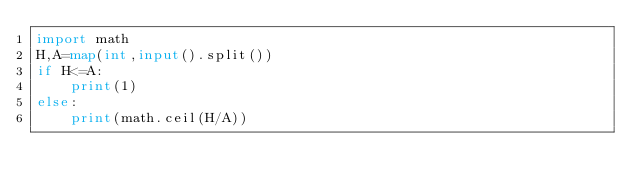<code> <loc_0><loc_0><loc_500><loc_500><_Python_>import math
H,A=map(int,input().split())
if H<=A:
    print(1)
else:
    print(math.ceil(H/A))</code> 